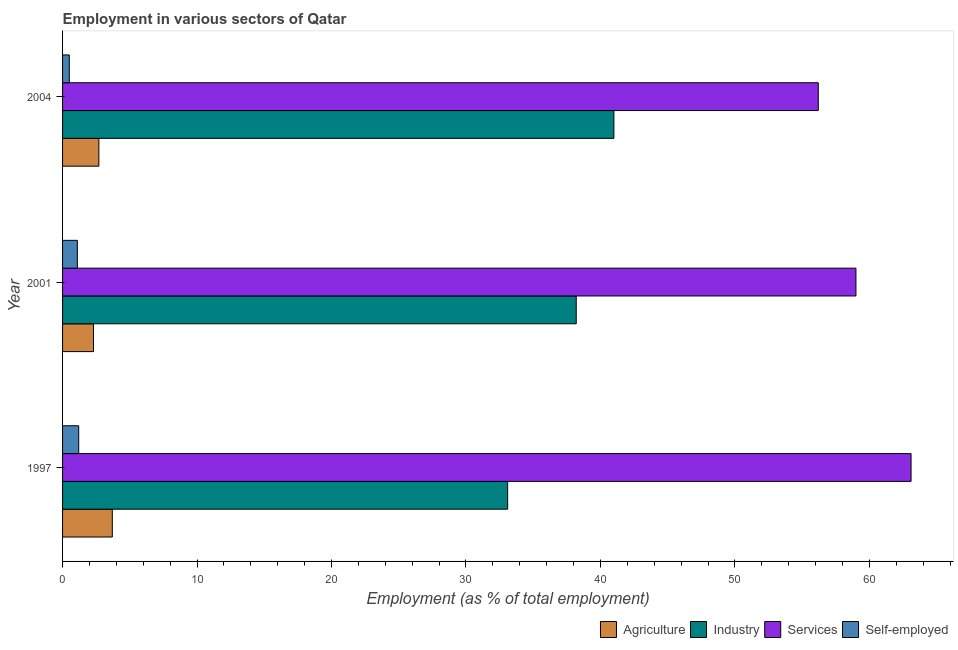How many different coloured bars are there?
Provide a succinct answer. 4. How many bars are there on the 2nd tick from the top?
Provide a short and direct response. 4. How many bars are there on the 1st tick from the bottom?
Provide a succinct answer. 4. What is the label of the 3rd group of bars from the top?
Your answer should be compact. 1997. In how many cases, is the number of bars for a given year not equal to the number of legend labels?
Provide a succinct answer. 0. What is the percentage of workers in industry in 1997?
Provide a succinct answer. 33.1. Across all years, what is the minimum percentage of workers in industry?
Keep it short and to the point. 33.1. What is the total percentage of self employed workers in the graph?
Provide a succinct answer. 2.8. What is the difference between the percentage of workers in industry in 2001 and that in 2004?
Offer a terse response. -2.8. What is the difference between the percentage of workers in agriculture in 2004 and the percentage of self employed workers in 2001?
Keep it short and to the point. 1.6. What is the average percentage of workers in agriculture per year?
Ensure brevity in your answer.  2.9. In the year 2001, what is the difference between the percentage of workers in industry and percentage of workers in agriculture?
Provide a succinct answer. 35.9. In how many years, is the percentage of workers in industry greater than 10 %?
Ensure brevity in your answer.  3. What is the ratio of the percentage of workers in services in 1997 to that in 2004?
Give a very brief answer. 1.12. Is the difference between the percentage of self employed workers in 2001 and 2004 greater than the difference between the percentage of workers in industry in 2001 and 2004?
Keep it short and to the point. Yes. What is the difference between the highest and the lowest percentage of workers in services?
Make the answer very short. 6.9. Is it the case that in every year, the sum of the percentage of workers in services and percentage of self employed workers is greater than the sum of percentage of workers in industry and percentage of workers in agriculture?
Your answer should be very brief. No. What does the 3rd bar from the top in 1997 represents?
Offer a terse response. Industry. What does the 2nd bar from the bottom in 2004 represents?
Offer a very short reply. Industry. Is it the case that in every year, the sum of the percentage of workers in agriculture and percentage of workers in industry is greater than the percentage of workers in services?
Keep it short and to the point. No. How many bars are there?
Keep it short and to the point. 12. How many years are there in the graph?
Keep it short and to the point. 3. Does the graph contain grids?
Make the answer very short. No. How are the legend labels stacked?
Your answer should be very brief. Horizontal. What is the title of the graph?
Offer a very short reply. Employment in various sectors of Qatar. What is the label or title of the X-axis?
Make the answer very short. Employment (as % of total employment). What is the Employment (as % of total employment) in Agriculture in 1997?
Your answer should be very brief. 3.7. What is the Employment (as % of total employment) of Industry in 1997?
Keep it short and to the point. 33.1. What is the Employment (as % of total employment) in Services in 1997?
Ensure brevity in your answer.  63.1. What is the Employment (as % of total employment) of Self-employed in 1997?
Offer a very short reply. 1.2. What is the Employment (as % of total employment) of Agriculture in 2001?
Keep it short and to the point. 2.3. What is the Employment (as % of total employment) in Industry in 2001?
Make the answer very short. 38.2. What is the Employment (as % of total employment) of Self-employed in 2001?
Your answer should be very brief. 1.1. What is the Employment (as % of total employment) in Agriculture in 2004?
Offer a very short reply. 2.7. What is the Employment (as % of total employment) of Industry in 2004?
Ensure brevity in your answer.  41. What is the Employment (as % of total employment) of Services in 2004?
Give a very brief answer. 56.2. Across all years, what is the maximum Employment (as % of total employment) in Agriculture?
Make the answer very short. 3.7. Across all years, what is the maximum Employment (as % of total employment) in Industry?
Give a very brief answer. 41. Across all years, what is the maximum Employment (as % of total employment) of Services?
Ensure brevity in your answer.  63.1. Across all years, what is the maximum Employment (as % of total employment) in Self-employed?
Your answer should be compact. 1.2. Across all years, what is the minimum Employment (as % of total employment) of Agriculture?
Your response must be concise. 2.3. Across all years, what is the minimum Employment (as % of total employment) in Industry?
Make the answer very short. 33.1. Across all years, what is the minimum Employment (as % of total employment) of Services?
Your answer should be compact. 56.2. Across all years, what is the minimum Employment (as % of total employment) of Self-employed?
Provide a short and direct response. 0.5. What is the total Employment (as % of total employment) of Agriculture in the graph?
Provide a succinct answer. 8.7. What is the total Employment (as % of total employment) of Industry in the graph?
Keep it short and to the point. 112.3. What is the total Employment (as % of total employment) of Services in the graph?
Your response must be concise. 178.3. What is the difference between the Employment (as % of total employment) of Services in 1997 and that in 2001?
Offer a terse response. 4.1. What is the difference between the Employment (as % of total employment) in Self-employed in 1997 and that in 2001?
Your answer should be very brief. 0.1. What is the difference between the Employment (as % of total employment) of Services in 1997 and that in 2004?
Your answer should be very brief. 6.9. What is the difference between the Employment (as % of total employment) in Self-employed in 1997 and that in 2004?
Offer a very short reply. 0.7. What is the difference between the Employment (as % of total employment) in Services in 2001 and that in 2004?
Make the answer very short. 2.8. What is the difference between the Employment (as % of total employment) of Agriculture in 1997 and the Employment (as % of total employment) of Industry in 2001?
Your answer should be very brief. -34.5. What is the difference between the Employment (as % of total employment) in Agriculture in 1997 and the Employment (as % of total employment) in Services in 2001?
Offer a very short reply. -55.3. What is the difference between the Employment (as % of total employment) of Agriculture in 1997 and the Employment (as % of total employment) of Self-employed in 2001?
Provide a short and direct response. 2.6. What is the difference between the Employment (as % of total employment) of Industry in 1997 and the Employment (as % of total employment) of Services in 2001?
Make the answer very short. -25.9. What is the difference between the Employment (as % of total employment) of Agriculture in 1997 and the Employment (as % of total employment) of Industry in 2004?
Your answer should be very brief. -37.3. What is the difference between the Employment (as % of total employment) in Agriculture in 1997 and the Employment (as % of total employment) in Services in 2004?
Make the answer very short. -52.5. What is the difference between the Employment (as % of total employment) in Agriculture in 1997 and the Employment (as % of total employment) in Self-employed in 2004?
Ensure brevity in your answer.  3.2. What is the difference between the Employment (as % of total employment) in Industry in 1997 and the Employment (as % of total employment) in Services in 2004?
Your answer should be very brief. -23.1. What is the difference between the Employment (as % of total employment) of Industry in 1997 and the Employment (as % of total employment) of Self-employed in 2004?
Ensure brevity in your answer.  32.6. What is the difference between the Employment (as % of total employment) of Services in 1997 and the Employment (as % of total employment) of Self-employed in 2004?
Offer a terse response. 62.6. What is the difference between the Employment (as % of total employment) in Agriculture in 2001 and the Employment (as % of total employment) in Industry in 2004?
Provide a succinct answer. -38.7. What is the difference between the Employment (as % of total employment) of Agriculture in 2001 and the Employment (as % of total employment) of Services in 2004?
Provide a short and direct response. -53.9. What is the difference between the Employment (as % of total employment) of Industry in 2001 and the Employment (as % of total employment) of Services in 2004?
Offer a terse response. -18. What is the difference between the Employment (as % of total employment) of Industry in 2001 and the Employment (as % of total employment) of Self-employed in 2004?
Your answer should be very brief. 37.7. What is the difference between the Employment (as % of total employment) in Services in 2001 and the Employment (as % of total employment) in Self-employed in 2004?
Offer a very short reply. 58.5. What is the average Employment (as % of total employment) of Industry per year?
Your answer should be compact. 37.43. What is the average Employment (as % of total employment) of Services per year?
Your response must be concise. 59.43. In the year 1997, what is the difference between the Employment (as % of total employment) of Agriculture and Employment (as % of total employment) of Industry?
Keep it short and to the point. -29.4. In the year 1997, what is the difference between the Employment (as % of total employment) of Agriculture and Employment (as % of total employment) of Services?
Your answer should be compact. -59.4. In the year 1997, what is the difference between the Employment (as % of total employment) of Agriculture and Employment (as % of total employment) of Self-employed?
Provide a short and direct response. 2.5. In the year 1997, what is the difference between the Employment (as % of total employment) of Industry and Employment (as % of total employment) of Self-employed?
Keep it short and to the point. 31.9. In the year 1997, what is the difference between the Employment (as % of total employment) in Services and Employment (as % of total employment) in Self-employed?
Provide a succinct answer. 61.9. In the year 2001, what is the difference between the Employment (as % of total employment) of Agriculture and Employment (as % of total employment) of Industry?
Make the answer very short. -35.9. In the year 2001, what is the difference between the Employment (as % of total employment) in Agriculture and Employment (as % of total employment) in Services?
Make the answer very short. -56.7. In the year 2001, what is the difference between the Employment (as % of total employment) of Agriculture and Employment (as % of total employment) of Self-employed?
Your answer should be very brief. 1.2. In the year 2001, what is the difference between the Employment (as % of total employment) in Industry and Employment (as % of total employment) in Services?
Provide a succinct answer. -20.8. In the year 2001, what is the difference between the Employment (as % of total employment) of Industry and Employment (as % of total employment) of Self-employed?
Offer a very short reply. 37.1. In the year 2001, what is the difference between the Employment (as % of total employment) of Services and Employment (as % of total employment) of Self-employed?
Your answer should be compact. 57.9. In the year 2004, what is the difference between the Employment (as % of total employment) in Agriculture and Employment (as % of total employment) in Industry?
Provide a succinct answer. -38.3. In the year 2004, what is the difference between the Employment (as % of total employment) in Agriculture and Employment (as % of total employment) in Services?
Make the answer very short. -53.5. In the year 2004, what is the difference between the Employment (as % of total employment) in Agriculture and Employment (as % of total employment) in Self-employed?
Keep it short and to the point. 2.2. In the year 2004, what is the difference between the Employment (as % of total employment) of Industry and Employment (as % of total employment) of Services?
Keep it short and to the point. -15.2. In the year 2004, what is the difference between the Employment (as % of total employment) in Industry and Employment (as % of total employment) in Self-employed?
Your answer should be very brief. 40.5. In the year 2004, what is the difference between the Employment (as % of total employment) of Services and Employment (as % of total employment) of Self-employed?
Your answer should be very brief. 55.7. What is the ratio of the Employment (as % of total employment) of Agriculture in 1997 to that in 2001?
Your answer should be compact. 1.61. What is the ratio of the Employment (as % of total employment) in Industry in 1997 to that in 2001?
Keep it short and to the point. 0.87. What is the ratio of the Employment (as % of total employment) of Services in 1997 to that in 2001?
Provide a succinct answer. 1.07. What is the ratio of the Employment (as % of total employment) of Agriculture in 1997 to that in 2004?
Your answer should be compact. 1.37. What is the ratio of the Employment (as % of total employment) of Industry in 1997 to that in 2004?
Offer a very short reply. 0.81. What is the ratio of the Employment (as % of total employment) of Services in 1997 to that in 2004?
Give a very brief answer. 1.12. What is the ratio of the Employment (as % of total employment) of Self-employed in 1997 to that in 2004?
Keep it short and to the point. 2.4. What is the ratio of the Employment (as % of total employment) in Agriculture in 2001 to that in 2004?
Your answer should be compact. 0.85. What is the ratio of the Employment (as % of total employment) of Industry in 2001 to that in 2004?
Give a very brief answer. 0.93. What is the ratio of the Employment (as % of total employment) of Services in 2001 to that in 2004?
Provide a succinct answer. 1.05. What is the ratio of the Employment (as % of total employment) in Self-employed in 2001 to that in 2004?
Provide a short and direct response. 2.2. What is the difference between the highest and the second highest Employment (as % of total employment) in Agriculture?
Make the answer very short. 1. What is the difference between the highest and the second highest Employment (as % of total employment) of Self-employed?
Ensure brevity in your answer.  0.1. What is the difference between the highest and the lowest Employment (as % of total employment) of Agriculture?
Your answer should be compact. 1.4. What is the difference between the highest and the lowest Employment (as % of total employment) in Industry?
Offer a terse response. 7.9. What is the difference between the highest and the lowest Employment (as % of total employment) of Self-employed?
Ensure brevity in your answer.  0.7. 